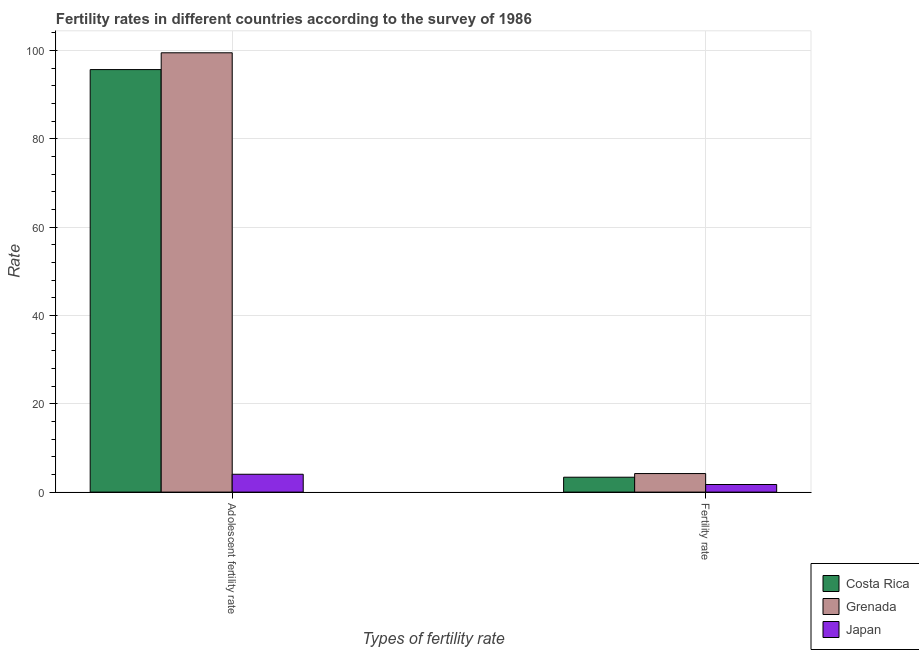What is the label of the 2nd group of bars from the left?
Offer a very short reply. Fertility rate. What is the fertility rate in Japan?
Give a very brief answer. 1.72. Across all countries, what is the minimum fertility rate?
Ensure brevity in your answer.  1.72. In which country was the fertility rate maximum?
Offer a very short reply. Grenada. In which country was the adolescent fertility rate minimum?
Keep it short and to the point. Japan. What is the total adolescent fertility rate in the graph?
Your response must be concise. 199.18. What is the difference between the adolescent fertility rate in Grenada and that in Japan?
Make the answer very short. 95.43. What is the difference between the fertility rate in Costa Rica and the adolescent fertility rate in Grenada?
Your response must be concise. -96.1. What is the average adolescent fertility rate per country?
Ensure brevity in your answer.  66.39. What is the difference between the fertility rate and adolescent fertility rate in Costa Rica?
Give a very brief answer. -92.3. In how many countries, is the adolescent fertility rate greater than 20 ?
Make the answer very short. 2. What is the ratio of the fertility rate in Japan to that in Grenada?
Your response must be concise. 0.41. What does the 2nd bar from the left in Adolescent fertility rate represents?
Provide a short and direct response. Grenada. What does the 1st bar from the right in Adolescent fertility rate represents?
Offer a terse response. Japan. Are all the bars in the graph horizontal?
Offer a terse response. No. What is the difference between two consecutive major ticks on the Y-axis?
Ensure brevity in your answer.  20. Are the values on the major ticks of Y-axis written in scientific E-notation?
Ensure brevity in your answer.  No. Does the graph contain any zero values?
Make the answer very short. No. Does the graph contain grids?
Your answer should be compact. Yes. How are the legend labels stacked?
Your answer should be compact. Vertical. What is the title of the graph?
Provide a succinct answer. Fertility rates in different countries according to the survey of 1986. What is the label or title of the X-axis?
Make the answer very short. Types of fertility rate. What is the label or title of the Y-axis?
Ensure brevity in your answer.  Rate. What is the Rate of Costa Rica in Adolescent fertility rate?
Keep it short and to the point. 95.67. What is the Rate in Grenada in Adolescent fertility rate?
Ensure brevity in your answer.  99.47. What is the Rate in Japan in Adolescent fertility rate?
Provide a short and direct response. 4.04. What is the Rate of Costa Rica in Fertility rate?
Offer a very short reply. 3.37. What is the Rate in Grenada in Fertility rate?
Provide a succinct answer. 4.2. What is the Rate of Japan in Fertility rate?
Offer a terse response. 1.72. Across all Types of fertility rate, what is the maximum Rate of Costa Rica?
Your answer should be compact. 95.67. Across all Types of fertility rate, what is the maximum Rate in Grenada?
Keep it short and to the point. 99.47. Across all Types of fertility rate, what is the maximum Rate in Japan?
Give a very brief answer. 4.04. Across all Types of fertility rate, what is the minimum Rate of Costa Rica?
Provide a succinct answer. 3.37. Across all Types of fertility rate, what is the minimum Rate in Japan?
Provide a short and direct response. 1.72. What is the total Rate in Costa Rica in the graph?
Offer a terse response. 99.04. What is the total Rate in Grenada in the graph?
Ensure brevity in your answer.  103.67. What is the total Rate of Japan in the graph?
Your response must be concise. 5.76. What is the difference between the Rate of Costa Rica in Adolescent fertility rate and that in Fertility rate?
Make the answer very short. 92.3. What is the difference between the Rate of Grenada in Adolescent fertility rate and that in Fertility rate?
Provide a short and direct response. 95.27. What is the difference between the Rate of Japan in Adolescent fertility rate and that in Fertility rate?
Keep it short and to the point. 2.32. What is the difference between the Rate of Costa Rica in Adolescent fertility rate and the Rate of Grenada in Fertility rate?
Keep it short and to the point. 91.47. What is the difference between the Rate of Costa Rica in Adolescent fertility rate and the Rate of Japan in Fertility rate?
Give a very brief answer. 93.95. What is the difference between the Rate in Grenada in Adolescent fertility rate and the Rate in Japan in Fertility rate?
Provide a succinct answer. 97.75. What is the average Rate in Costa Rica per Types of fertility rate?
Ensure brevity in your answer.  49.52. What is the average Rate of Grenada per Types of fertility rate?
Ensure brevity in your answer.  51.84. What is the average Rate in Japan per Types of fertility rate?
Provide a short and direct response. 2.88. What is the difference between the Rate of Costa Rica and Rate of Grenada in Adolescent fertility rate?
Provide a succinct answer. -3.8. What is the difference between the Rate of Costa Rica and Rate of Japan in Adolescent fertility rate?
Give a very brief answer. 91.63. What is the difference between the Rate of Grenada and Rate of Japan in Adolescent fertility rate?
Make the answer very short. 95.43. What is the difference between the Rate in Costa Rica and Rate in Grenada in Fertility rate?
Provide a short and direct response. -0.83. What is the difference between the Rate in Costa Rica and Rate in Japan in Fertility rate?
Offer a terse response. 1.65. What is the difference between the Rate of Grenada and Rate of Japan in Fertility rate?
Provide a short and direct response. 2.48. What is the ratio of the Rate of Costa Rica in Adolescent fertility rate to that in Fertility rate?
Your answer should be very brief. 28.38. What is the ratio of the Rate of Grenada in Adolescent fertility rate to that in Fertility rate?
Make the answer very short. 23.68. What is the ratio of the Rate in Japan in Adolescent fertility rate to that in Fertility rate?
Ensure brevity in your answer.  2.35. What is the difference between the highest and the second highest Rate in Costa Rica?
Your answer should be compact. 92.3. What is the difference between the highest and the second highest Rate of Grenada?
Offer a terse response. 95.27. What is the difference between the highest and the second highest Rate of Japan?
Your response must be concise. 2.32. What is the difference between the highest and the lowest Rate in Costa Rica?
Offer a very short reply. 92.3. What is the difference between the highest and the lowest Rate in Grenada?
Provide a short and direct response. 95.27. What is the difference between the highest and the lowest Rate in Japan?
Give a very brief answer. 2.32. 